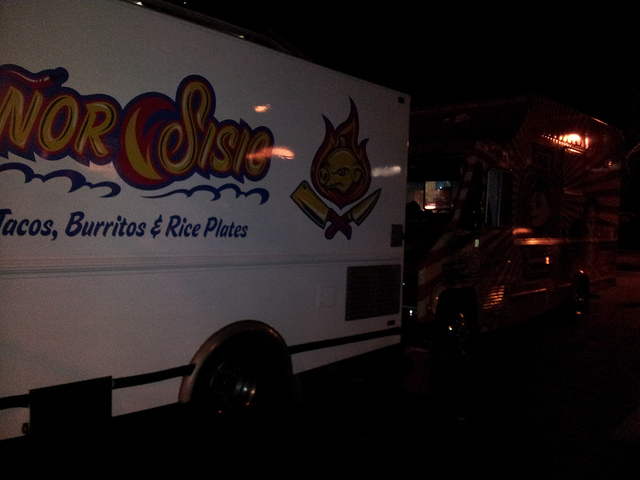<image>What is Bristol? I don't know what Bristol refers to in this context. It can be a city in England, a food truck, a town, a place, a restaurant or even mexican food. What is Bristol? I don't know what Bristol is. It can be a food truck, a truck, a city in England, a town, a place, or a restaurant. 